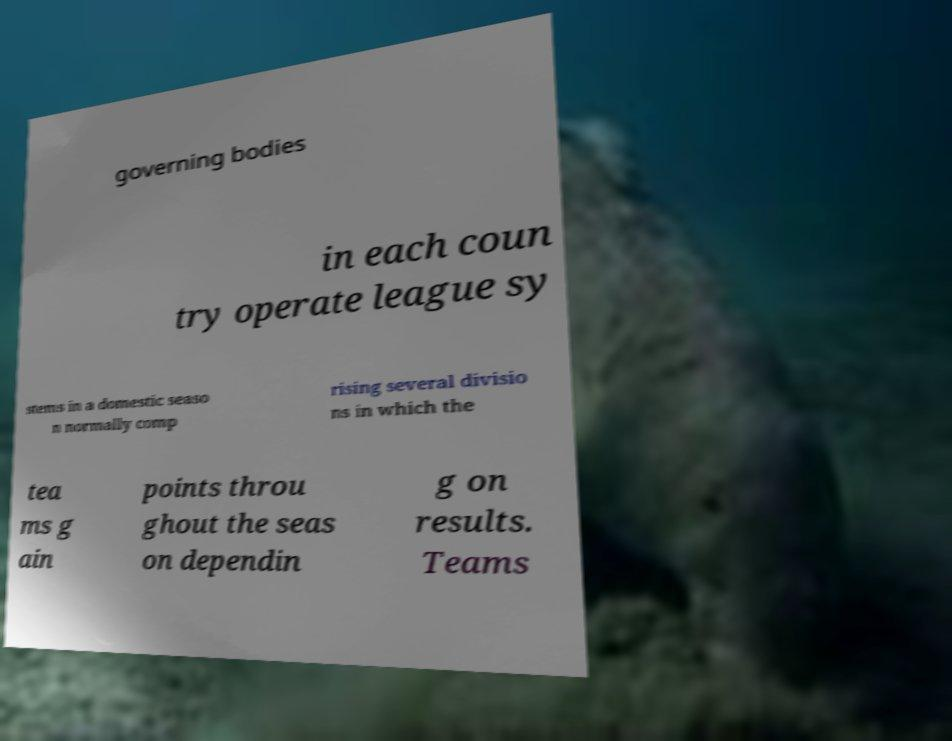Could you assist in decoding the text presented in this image and type it out clearly? governing bodies in each coun try operate league sy stems in a domestic seaso n normally comp rising several divisio ns in which the tea ms g ain points throu ghout the seas on dependin g on results. Teams 